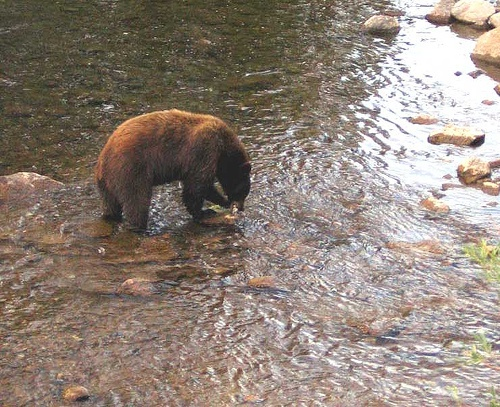Describe the objects in this image and their specific colors. I can see a bear in gray, black, and maroon tones in this image. 